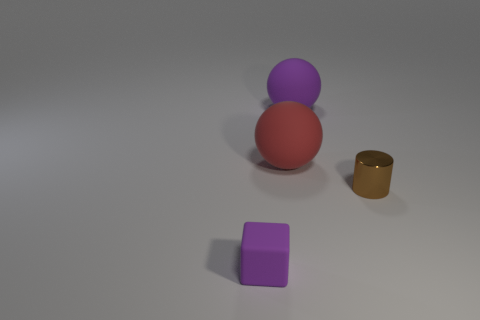Add 2 red balls. How many objects exist? 6 Subtract all cylinders. How many objects are left? 3 Subtract 2 balls. How many balls are left? 0 Subtract all shiny objects. Subtract all small brown cylinders. How many objects are left? 2 Add 2 tiny metal cylinders. How many tiny metal cylinders are left? 3 Add 2 cubes. How many cubes exist? 3 Subtract 0 blue cubes. How many objects are left? 4 Subtract all cyan cylinders. Subtract all blue cubes. How many cylinders are left? 1 Subtract all yellow cylinders. How many yellow cubes are left? 0 